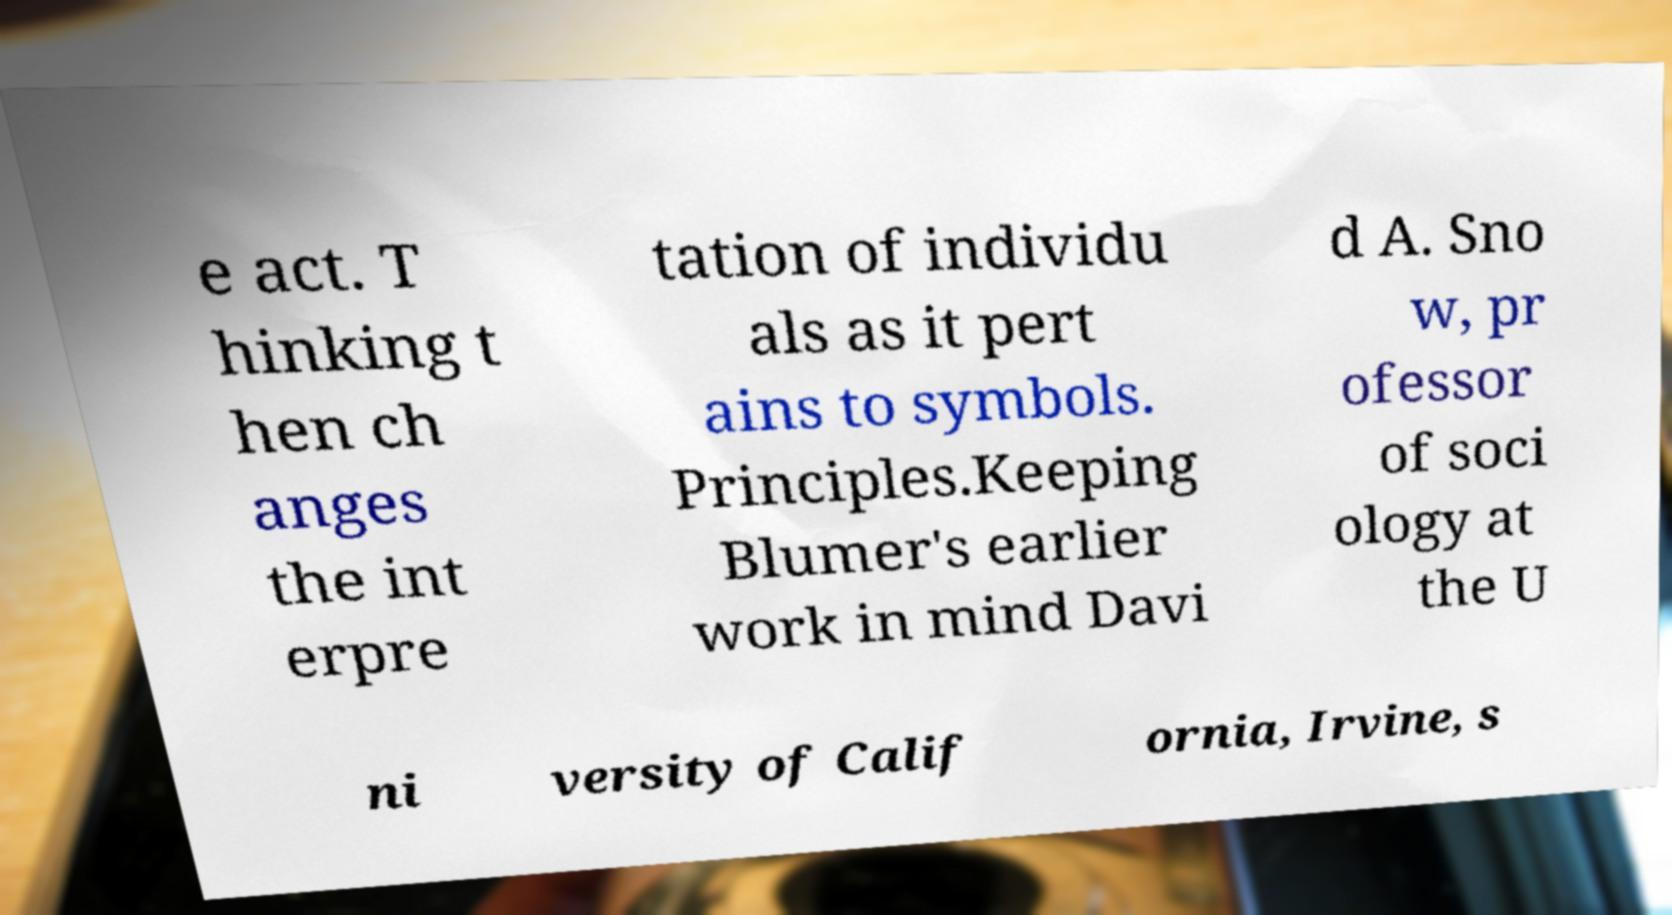Could you extract and type out the text from this image? e act. T hinking t hen ch anges the int erpre tation of individu als as it pert ains to symbols. Principles.Keeping Blumer's earlier work in mind Davi d A. Sno w, pr ofessor of soci ology at the U ni versity of Calif ornia, Irvine, s 